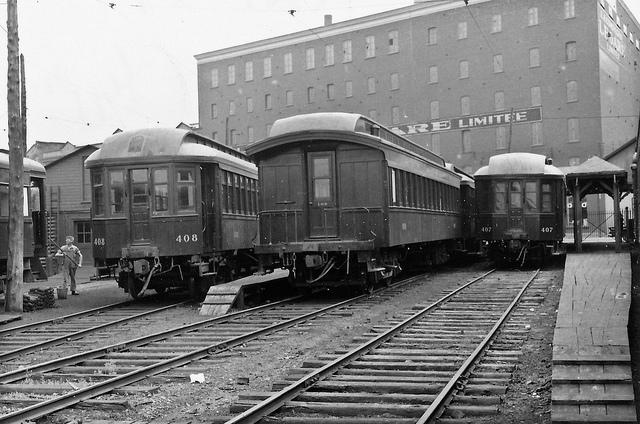What are the pants type the man is wearing?

Choices:
A) overalls
B) stonewashed jeans
C) slacks
D) khakis overalls 